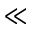<formula> <loc_0><loc_0><loc_500><loc_500>\ll</formula> 